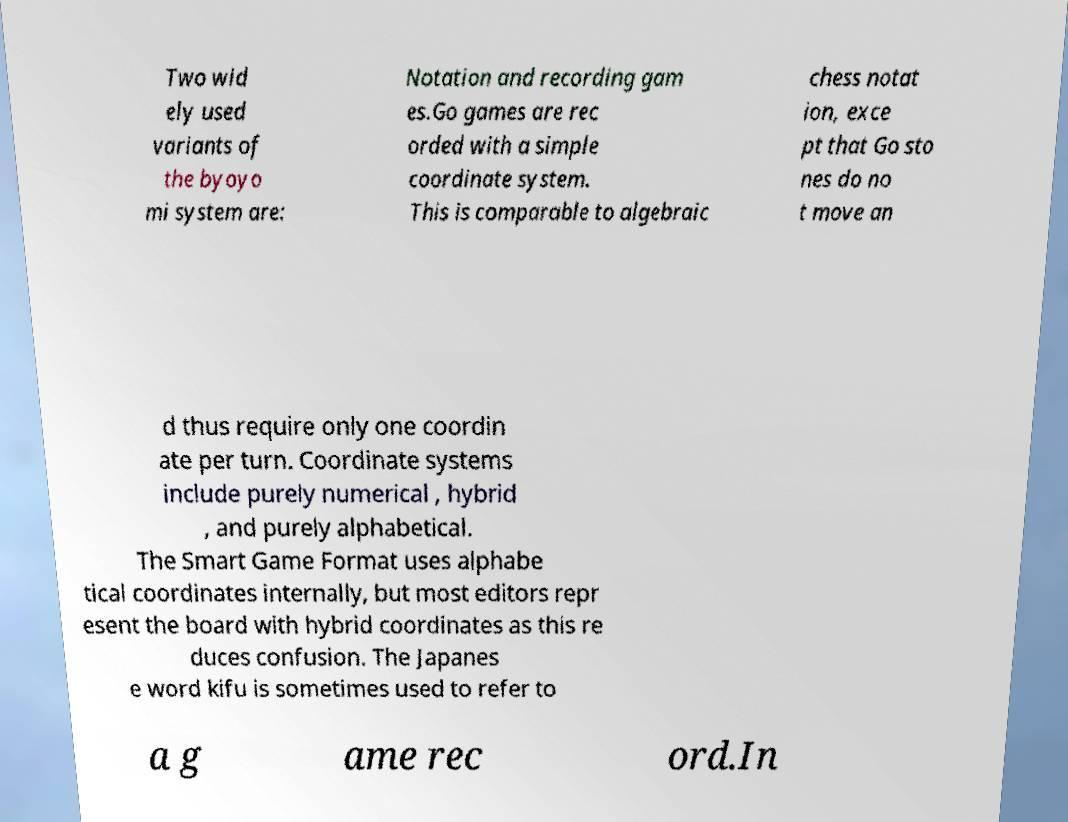There's text embedded in this image that I need extracted. Can you transcribe it verbatim? Two wid ely used variants of the byoyo mi system are: Notation and recording gam es.Go games are rec orded with a simple coordinate system. This is comparable to algebraic chess notat ion, exce pt that Go sto nes do no t move an d thus require only one coordin ate per turn. Coordinate systems include purely numerical , hybrid , and purely alphabetical. The Smart Game Format uses alphabe tical coordinates internally, but most editors repr esent the board with hybrid coordinates as this re duces confusion. The Japanes e word kifu is sometimes used to refer to a g ame rec ord.In 